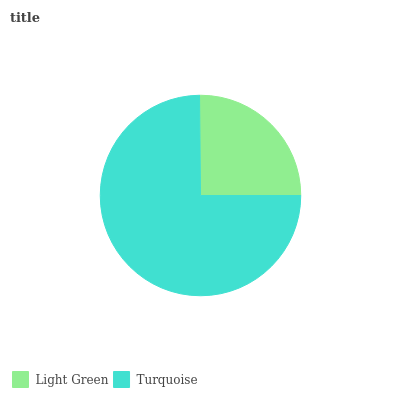Is Light Green the minimum?
Answer yes or no. Yes. Is Turquoise the maximum?
Answer yes or no. Yes. Is Turquoise the minimum?
Answer yes or no. No. Is Turquoise greater than Light Green?
Answer yes or no. Yes. Is Light Green less than Turquoise?
Answer yes or no. Yes. Is Light Green greater than Turquoise?
Answer yes or no. No. Is Turquoise less than Light Green?
Answer yes or no. No. Is Turquoise the high median?
Answer yes or no. Yes. Is Light Green the low median?
Answer yes or no. Yes. Is Light Green the high median?
Answer yes or no. No. Is Turquoise the low median?
Answer yes or no. No. 